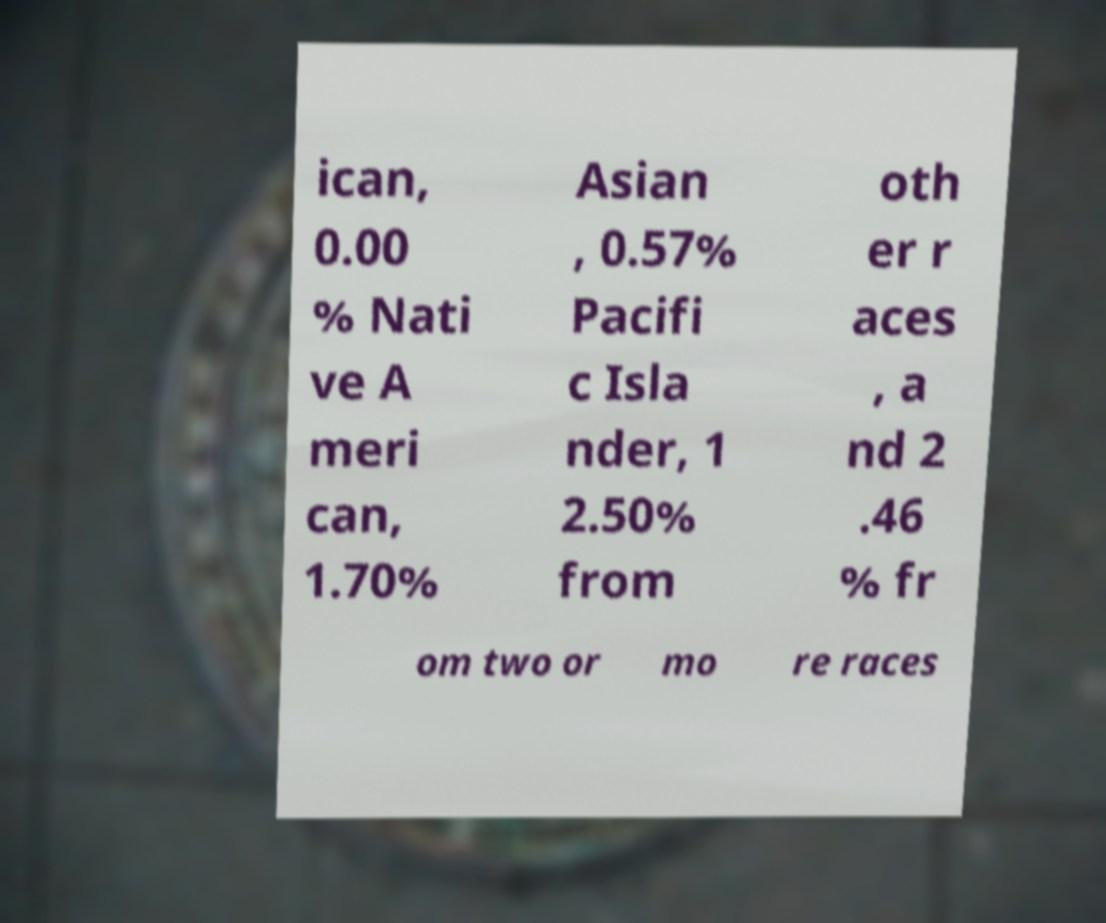Can you accurately transcribe the text from the provided image for me? ican, 0.00 % Nati ve A meri can, 1.70% Asian , 0.57% Pacifi c Isla nder, 1 2.50% from oth er r aces , a nd 2 .46 % fr om two or mo re races 